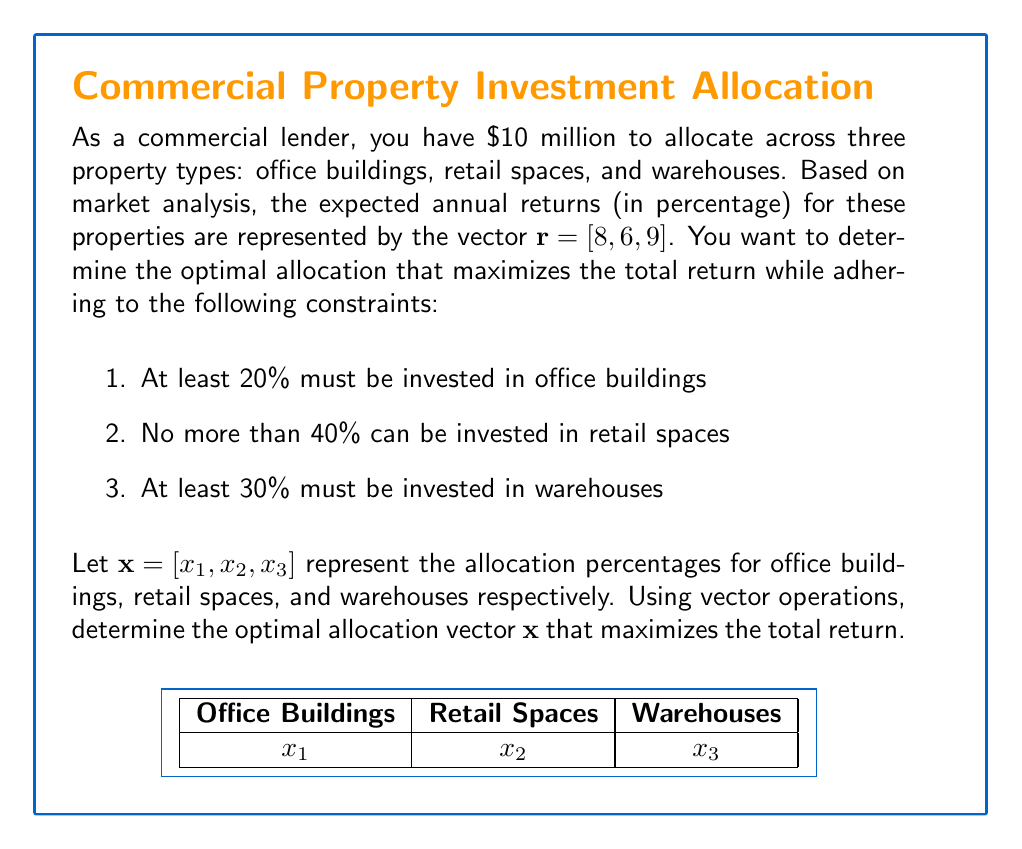Teach me how to tackle this problem. To solve this problem, we'll follow these steps:

1) First, we need to set up the optimization problem. We want to maximize the dot product of the returns vector and the allocation vector:

   $\text{Maximize } \mathbf{r} \cdot \mathbf{x} = 8x_1 + 6x_2 + 9x_3$

2) Subject to the following constraints:
   
   $x_1 \geq 0.2$ (at least 20% in office buildings)
   $x_2 \leq 0.4$ (no more than 40% in retail spaces)
   $x_3 \geq 0.3$ (at least 30% in warehouses)
   $x_1 + x_2 + x_3 = 1$ (total allocation must be 100%)

3) Given these constraints, we can deduce that the remaining 10% (1 - 0.2 - 0.4 - 0.3) can be allocated to either office buildings or warehouses, as they have higher returns than retail spaces.

4) Since warehouses have the highest return (9%), we should allocate the maximum possible to warehouses while meeting all constraints. This means allocating 40% to warehouses.

5) The remaining allocation should go to office buildings, which have the next highest return. This will be 30%.

6) For retail spaces, we allocate the minimum required to meet the constraints, which is 30%.

Therefore, the optimal allocation vector is:

$\mathbf{x} = [0.3, 0.3, 0.4]$

We can verify that this satisfies all constraints and maximizes the return:

$\mathbf{r} \cdot \mathbf{x} = 8(0.3) + 6(0.3) + 9(0.4) = 2.4 + 1.8 + 3.6 = 7.8$

This represents a 7.8% expected annual return on the $10 million investment.
Answer: $\mathbf{x} = [0.3, 0.3, 0.4]$ 